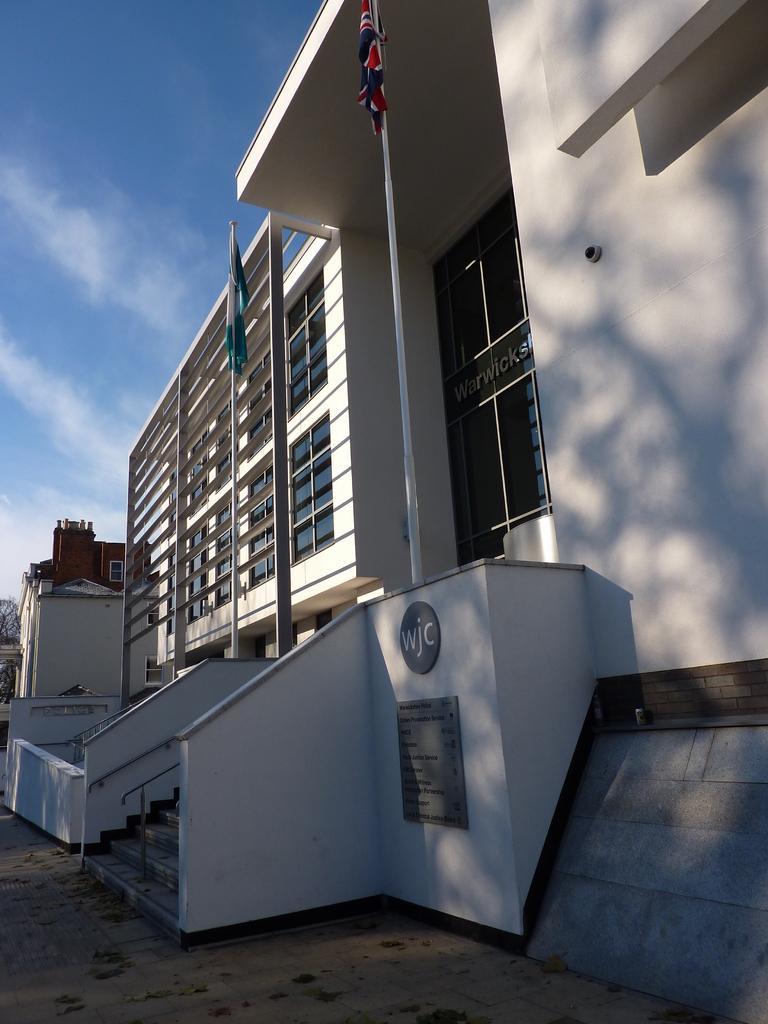Can you describe this image briefly? In this image there are buildings. In front of the buildings there are flags to the poles. There are steps to the building. There is a railing beside the steps. There are boards with text on the walls of the building. At the top there is the sky. At the bottom there is the ground. 